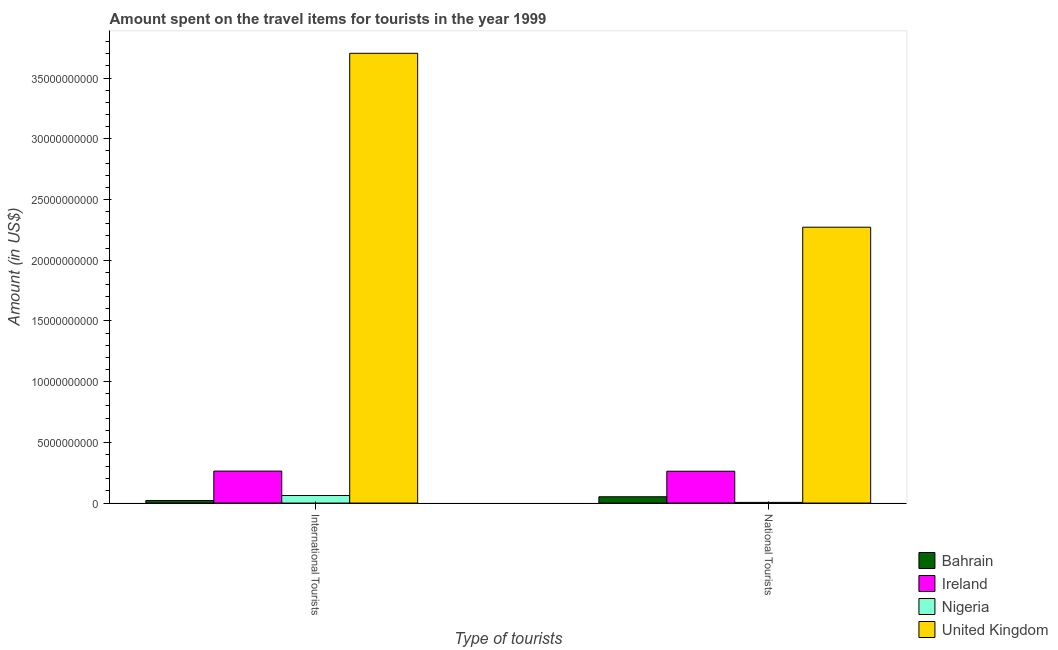How many different coloured bars are there?
Make the answer very short. 4. How many groups of bars are there?
Ensure brevity in your answer.  2. Are the number of bars per tick equal to the number of legend labels?
Your answer should be very brief. Yes. Are the number of bars on each tick of the X-axis equal?
Your answer should be compact. Yes. How many bars are there on the 2nd tick from the left?
Give a very brief answer. 4. How many bars are there on the 2nd tick from the right?
Make the answer very short. 4. What is the label of the 2nd group of bars from the left?
Your response must be concise. National Tourists. What is the amount spent on travel items of national tourists in Nigeria?
Keep it short and to the point. 5.40e+07. Across all countries, what is the maximum amount spent on travel items of national tourists?
Make the answer very short. 2.27e+1. Across all countries, what is the minimum amount spent on travel items of international tourists?
Keep it short and to the point. 2.12e+08. In which country was the amount spent on travel items of national tourists maximum?
Make the answer very short. United Kingdom. In which country was the amount spent on travel items of international tourists minimum?
Your answer should be very brief. Bahrain. What is the total amount spent on travel items of international tourists in the graph?
Provide a succinct answer. 4.05e+1. What is the difference between the amount spent on travel items of national tourists in Bahrain and that in Ireland?
Give a very brief answer. -2.10e+09. What is the difference between the amount spent on travel items of international tourists in United Kingdom and the amount spent on travel items of national tourists in Ireland?
Provide a succinct answer. 3.44e+1. What is the average amount spent on travel items of international tourists per country?
Your answer should be compact. 1.01e+1. What is the difference between the amount spent on travel items of national tourists and amount spent on travel items of international tourists in Nigeria?
Your response must be concise. -5.66e+08. What is the ratio of the amount spent on travel items of national tourists in Ireland to that in United Kingdom?
Your answer should be very brief. 0.12. Is the amount spent on travel items of international tourists in United Kingdom less than that in Ireland?
Ensure brevity in your answer.  No. What does the 4th bar from the left in International Tourists represents?
Offer a very short reply. United Kingdom. What does the 3rd bar from the right in International Tourists represents?
Provide a succinct answer. Ireland. How many bars are there?
Your answer should be very brief. 8. Are all the bars in the graph horizontal?
Provide a succinct answer. No. Does the graph contain grids?
Offer a very short reply. No. How many legend labels are there?
Make the answer very short. 4. How are the legend labels stacked?
Ensure brevity in your answer.  Vertical. What is the title of the graph?
Ensure brevity in your answer.  Amount spent on the travel items for tourists in the year 1999. Does "Palau" appear as one of the legend labels in the graph?
Make the answer very short. No. What is the label or title of the X-axis?
Provide a short and direct response. Type of tourists. What is the label or title of the Y-axis?
Offer a terse response. Amount (in US$). What is the Amount (in US$) in Bahrain in International Tourists?
Keep it short and to the point. 2.12e+08. What is the Amount (in US$) in Ireland in International Tourists?
Keep it short and to the point. 2.63e+09. What is the Amount (in US$) of Nigeria in International Tourists?
Make the answer very short. 6.20e+08. What is the Amount (in US$) in United Kingdom in International Tourists?
Your answer should be compact. 3.70e+1. What is the Amount (in US$) of Bahrain in National Tourists?
Give a very brief answer. 5.18e+08. What is the Amount (in US$) in Ireland in National Tourists?
Your answer should be compact. 2.62e+09. What is the Amount (in US$) in Nigeria in National Tourists?
Keep it short and to the point. 5.40e+07. What is the Amount (in US$) in United Kingdom in National Tourists?
Give a very brief answer. 2.27e+1. Across all Type of tourists, what is the maximum Amount (in US$) of Bahrain?
Provide a succinct answer. 5.18e+08. Across all Type of tourists, what is the maximum Amount (in US$) of Ireland?
Provide a succinct answer. 2.63e+09. Across all Type of tourists, what is the maximum Amount (in US$) in Nigeria?
Make the answer very short. 6.20e+08. Across all Type of tourists, what is the maximum Amount (in US$) in United Kingdom?
Your answer should be compact. 3.70e+1. Across all Type of tourists, what is the minimum Amount (in US$) of Bahrain?
Your answer should be very brief. 2.12e+08. Across all Type of tourists, what is the minimum Amount (in US$) of Ireland?
Provide a short and direct response. 2.62e+09. Across all Type of tourists, what is the minimum Amount (in US$) of Nigeria?
Give a very brief answer. 5.40e+07. Across all Type of tourists, what is the minimum Amount (in US$) of United Kingdom?
Provide a succinct answer. 2.27e+1. What is the total Amount (in US$) of Bahrain in the graph?
Your answer should be compact. 7.30e+08. What is the total Amount (in US$) in Ireland in the graph?
Your answer should be very brief. 5.25e+09. What is the total Amount (in US$) of Nigeria in the graph?
Offer a very short reply. 6.74e+08. What is the total Amount (in US$) of United Kingdom in the graph?
Keep it short and to the point. 5.98e+1. What is the difference between the Amount (in US$) in Bahrain in International Tourists and that in National Tourists?
Offer a terse response. -3.06e+08. What is the difference between the Amount (in US$) in Ireland in International Tourists and that in National Tourists?
Your response must be concise. 1.00e+07. What is the difference between the Amount (in US$) of Nigeria in International Tourists and that in National Tourists?
Offer a terse response. 5.66e+08. What is the difference between the Amount (in US$) in United Kingdom in International Tourists and that in National Tourists?
Keep it short and to the point. 1.43e+1. What is the difference between the Amount (in US$) of Bahrain in International Tourists and the Amount (in US$) of Ireland in National Tourists?
Your answer should be very brief. -2.41e+09. What is the difference between the Amount (in US$) of Bahrain in International Tourists and the Amount (in US$) of Nigeria in National Tourists?
Make the answer very short. 1.58e+08. What is the difference between the Amount (in US$) of Bahrain in International Tourists and the Amount (in US$) of United Kingdom in National Tourists?
Make the answer very short. -2.25e+1. What is the difference between the Amount (in US$) of Ireland in International Tourists and the Amount (in US$) of Nigeria in National Tourists?
Your answer should be compact. 2.58e+09. What is the difference between the Amount (in US$) in Ireland in International Tourists and the Amount (in US$) in United Kingdom in National Tourists?
Ensure brevity in your answer.  -2.01e+1. What is the difference between the Amount (in US$) of Nigeria in International Tourists and the Amount (in US$) of United Kingdom in National Tourists?
Your answer should be compact. -2.21e+1. What is the average Amount (in US$) in Bahrain per Type of tourists?
Offer a terse response. 3.65e+08. What is the average Amount (in US$) of Ireland per Type of tourists?
Provide a succinct answer. 2.63e+09. What is the average Amount (in US$) in Nigeria per Type of tourists?
Give a very brief answer. 3.37e+08. What is the average Amount (in US$) of United Kingdom per Type of tourists?
Offer a very short reply. 2.99e+1. What is the difference between the Amount (in US$) of Bahrain and Amount (in US$) of Ireland in International Tourists?
Offer a very short reply. -2.42e+09. What is the difference between the Amount (in US$) in Bahrain and Amount (in US$) in Nigeria in International Tourists?
Offer a very short reply. -4.08e+08. What is the difference between the Amount (in US$) of Bahrain and Amount (in US$) of United Kingdom in International Tourists?
Offer a very short reply. -3.68e+1. What is the difference between the Amount (in US$) in Ireland and Amount (in US$) in Nigeria in International Tourists?
Offer a very short reply. 2.01e+09. What is the difference between the Amount (in US$) in Ireland and Amount (in US$) in United Kingdom in International Tourists?
Your answer should be very brief. -3.44e+1. What is the difference between the Amount (in US$) of Nigeria and Amount (in US$) of United Kingdom in International Tourists?
Your response must be concise. -3.64e+1. What is the difference between the Amount (in US$) in Bahrain and Amount (in US$) in Ireland in National Tourists?
Provide a short and direct response. -2.10e+09. What is the difference between the Amount (in US$) of Bahrain and Amount (in US$) of Nigeria in National Tourists?
Your answer should be very brief. 4.64e+08. What is the difference between the Amount (in US$) in Bahrain and Amount (in US$) in United Kingdom in National Tourists?
Make the answer very short. -2.22e+1. What is the difference between the Amount (in US$) in Ireland and Amount (in US$) in Nigeria in National Tourists?
Provide a succinct answer. 2.57e+09. What is the difference between the Amount (in US$) in Ireland and Amount (in US$) in United Kingdom in National Tourists?
Offer a very short reply. -2.01e+1. What is the difference between the Amount (in US$) of Nigeria and Amount (in US$) of United Kingdom in National Tourists?
Offer a very short reply. -2.27e+1. What is the ratio of the Amount (in US$) of Bahrain in International Tourists to that in National Tourists?
Offer a very short reply. 0.41. What is the ratio of the Amount (in US$) of Ireland in International Tourists to that in National Tourists?
Ensure brevity in your answer.  1. What is the ratio of the Amount (in US$) of Nigeria in International Tourists to that in National Tourists?
Your response must be concise. 11.48. What is the ratio of the Amount (in US$) in United Kingdom in International Tourists to that in National Tourists?
Your response must be concise. 1.63. What is the difference between the highest and the second highest Amount (in US$) of Bahrain?
Offer a very short reply. 3.06e+08. What is the difference between the highest and the second highest Amount (in US$) in Ireland?
Your answer should be very brief. 1.00e+07. What is the difference between the highest and the second highest Amount (in US$) in Nigeria?
Offer a very short reply. 5.66e+08. What is the difference between the highest and the second highest Amount (in US$) in United Kingdom?
Give a very brief answer. 1.43e+1. What is the difference between the highest and the lowest Amount (in US$) in Bahrain?
Provide a short and direct response. 3.06e+08. What is the difference between the highest and the lowest Amount (in US$) of Nigeria?
Give a very brief answer. 5.66e+08. What is the difference between the highest and the lowest Amount (in US$) of United Kingdom?
Give a very brief answer. 1.43e+1. 